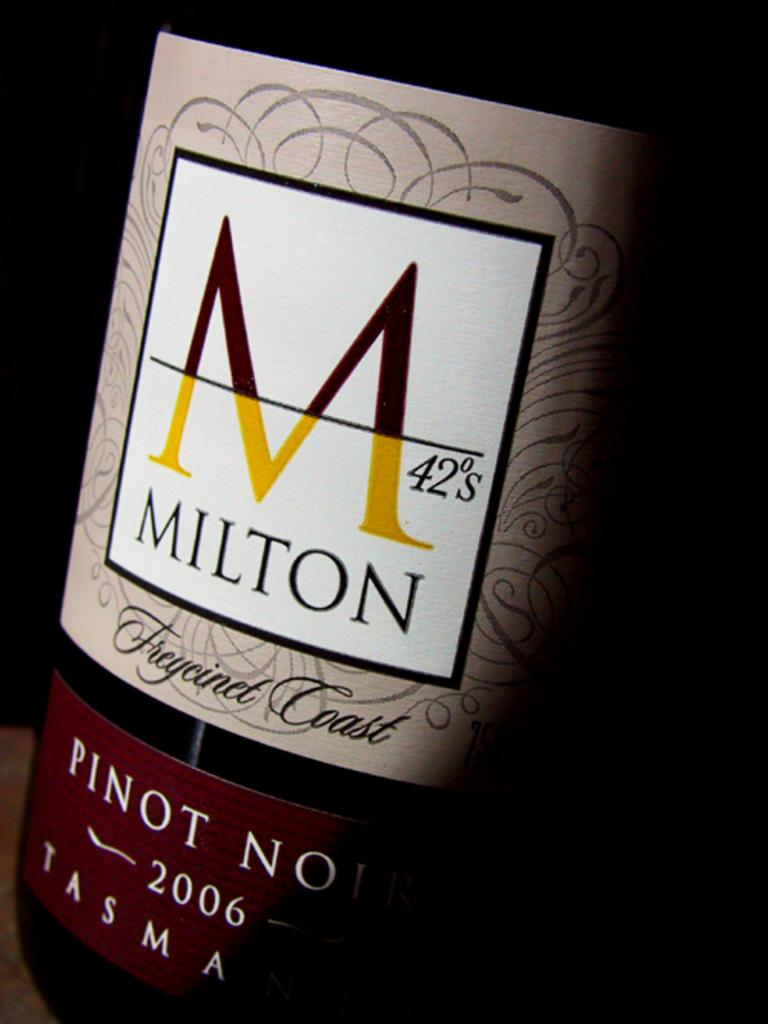What object can be seen in the image? There is a bottle in the image. What is unique about the appearance of the bottle? The bottle has stickers on it. Can you describe the background of the image? The background of the image is dark. How many toes can be seen on the bottle in the image? There are no toes present in the image; it features a bottle with stickers on it. 